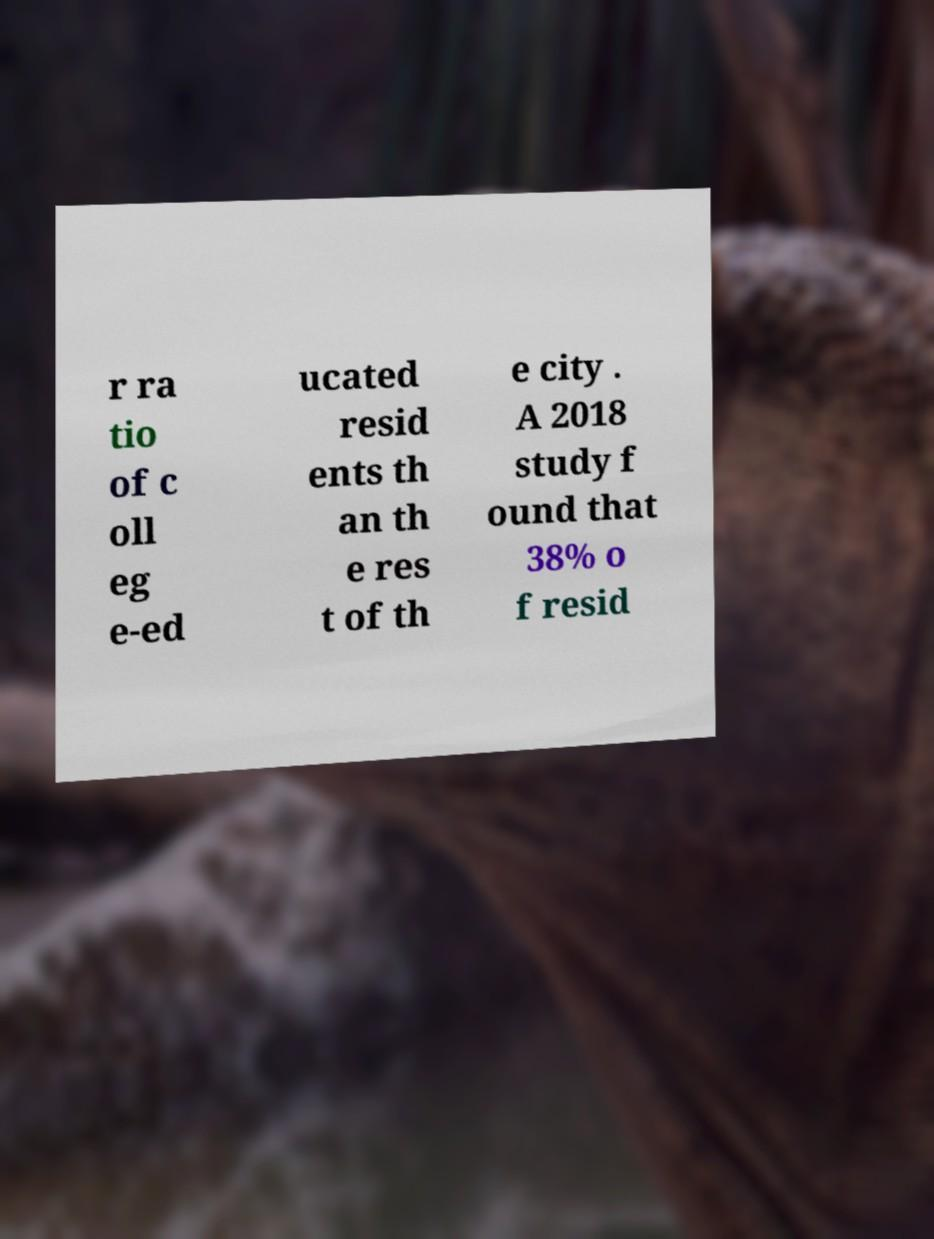For documentation purposes, I need the text within this image transcribed. Could you provide that? r ra tio of c oll eg e-ed ucated resid ents th an th e res t of th e city . A 2018 study f ound that 38% o f resid 